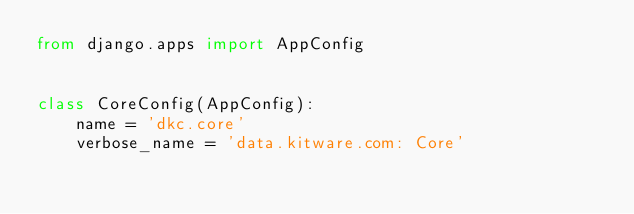<code> <loc_0><loc_0><loc_500><loc_500><_Python_>from django.apps import AppConfig


class CoreConfig(AppConfig):
    name = 'dkc.core'
    verbose_name = 'data.kitware.com: Core'
</code> 